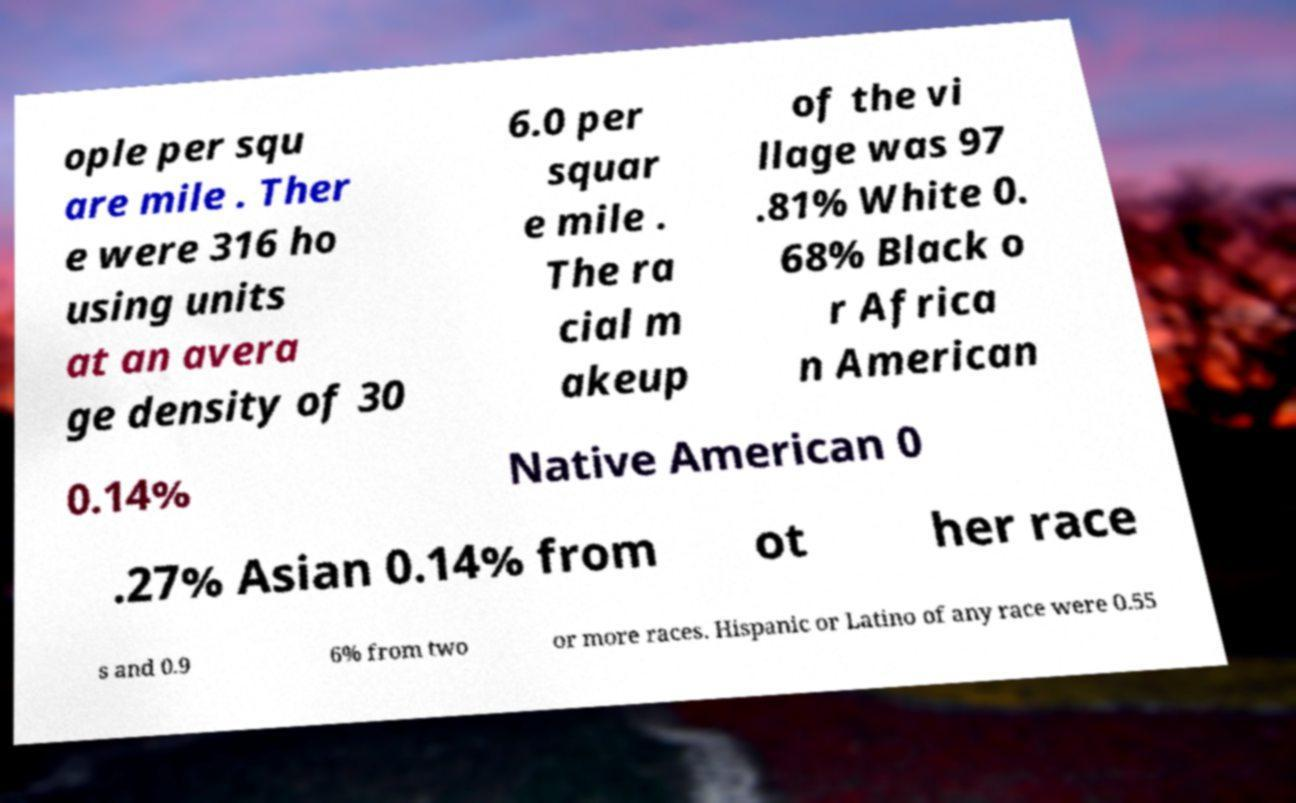Can you accurately transcribe the text from the provided image for me? ople per squ are mile . Ther e were 316 ho using units at an avera ge density of 30 6.0 per squar e mile . The ra cial m akeup of the vi llage was 97 .81% White 0. 68% Black o r Africa n American 0.14% Native American 0 .27% Asian 0.14% from ot her race s and 0.9 6% from two or more races. Hispanic or Latino of any race were 0.55 